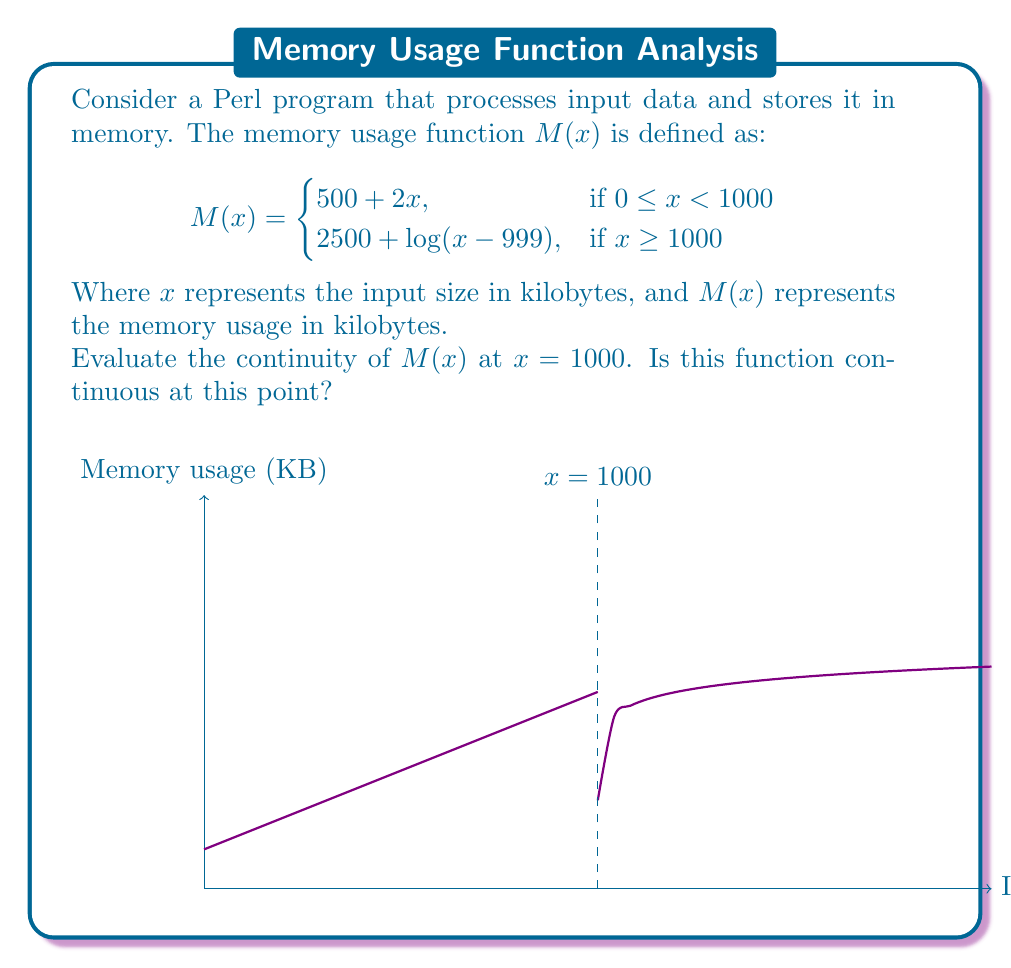Teach me how to tackle this problem. To evaluate the continuity of $M(x)$ at $x = 1000$, we need to check three conditions:

1. $M(x)$ is defined at $x = 1000$
2. $\lim_{x \to 1000^-} M(x)$ exists
3. $\lim_{x \to 1000^+} M(x)$ exists
4. $\lim_{x \to 1000^-} M(x) = \lim_{x \to 1000^+} M(x) = M(1000)$

Let's check each condition:

1. $M(1000)$ is defined:
   $M(1000) = 2500 + \log(1000-999) = 2500 + \log(1) = 2500$

2. $\lim_{x \to 1000^-} M(x)$:
   $$\lim_{x \to 1000^-} M(x) = \lim_{x \to 1000^-} (500 + 2x) = 500 + 2(1000) = 2500$$

3. $\lim_{x \to 1000^+} M(x)$:
   $$\lim_{x \to 1000^+} M(x) = \lim_{x \to 1000^+} (2500 + \log(x-999)) = 2500 + \log(1) = 2500$$

4. Comparing the limits and function value:
   $$\lim_{x \to 1000^-} M(x) = \lim_{x \to 1000^+} M(x) = M(1000) = 2500$$

Since all four conditions are satisfied, the function $M(x)$ is continuous at $x = 1000$.

This continuity ensures that the memory usage of the Perl program transitions smoothly as the input size reaches and exceeds 1000 KB, which is crucial for maintaining consistent performance and avoiding sudden memory spikes.
Answer: $M(x)$ is continuous at $x = 1000$. 